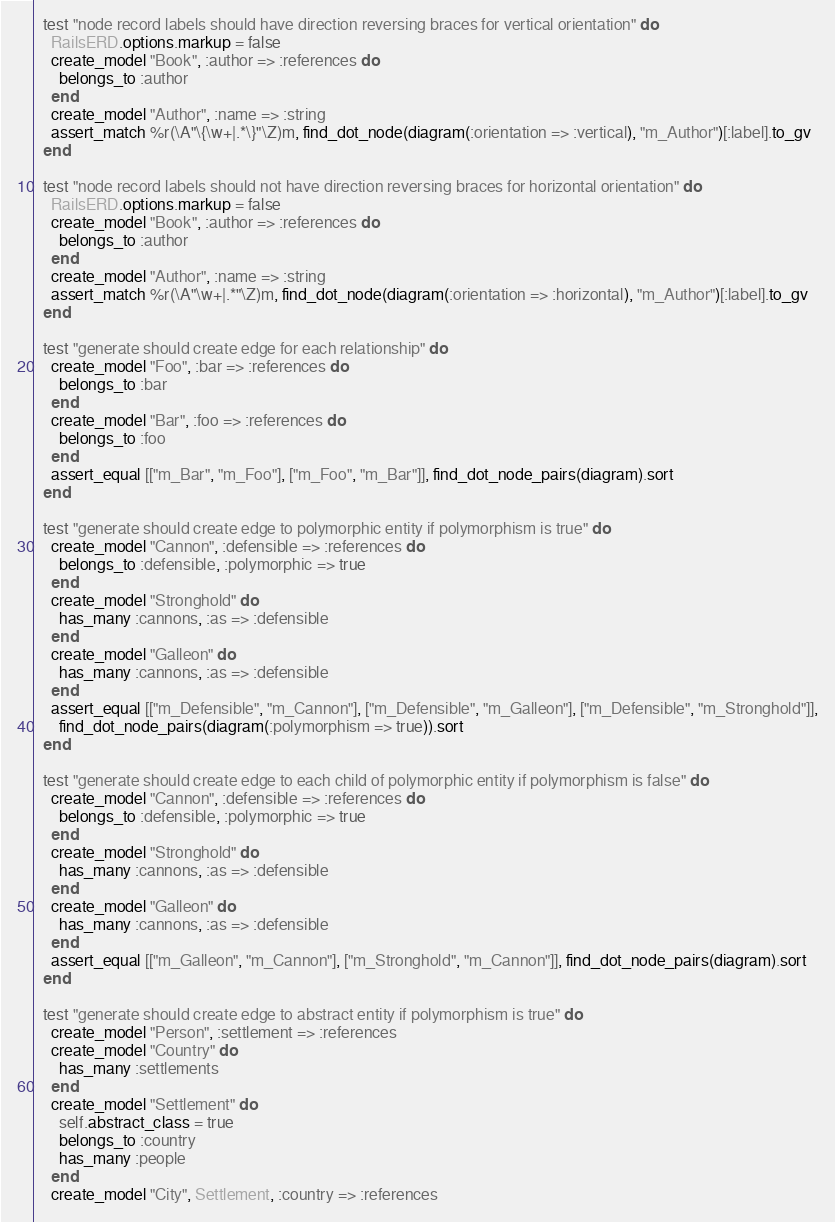<code> <loc_0><loc_0><loc_500><loc_500><_Ruby_>
  test "node record labels should have direction reversing braces for vertical orientation" do
    RailsERD.options.markup = false
    create_model "Book", :author => :references do
      belongs_to :author
    end
    create_model "Author", :name => :string
    assert_match %r(\A"\{\w+|.*\}"\Z)m, find_dot_node(diagram(:orientation => :vertical), "m_Author")[:label].to_gv
  end

  test "node record labels should not have direction reversing braces for horizontal orientation" do
    RailsERD.options.markup = false
    create_model "Book", :author => :references do
      belongs_to :author
    end
    create_model "Author", :name => :string
    assert_match %r(\A"\w+|.*"\Z)m, find_dot_node(diagram(:orientation => :horizontal), "m_Author")[:label].to_gv
  end

  test "generate should create edge for each relationship" do
    create_model "Foo", :bar => :references do
      belongs_to :bar
    end
    create_model "Bar", :foo => :references do
      belongs_to :foo
    end
    assert_equal [["m_Bar", "m_Foo"], ["m_Foo", "m_Bar"]], find_dot_node_pairs(diagram).sort
  end

  test "generate should create edge to polymorphic entity if polymorphism is true" do
    create_model "Cannon", :defensible => :references do
      belongs_to :defensible, :polymorphic => true
    end
    create_model "Stronghold" do
      has_many :cannons, :as => :defensible
    end
    create_model "Galleon" do
      has_many :cannons, :as => :defensible
    end
    assert_equal [["m_Defensible", "m_Cannon"], ["m_Defensible", "m_Galleon"], ["m_Defensible", "m_Stronghold"]],
      find_dot_node_pairs(diagram(:polymorphism => true)).sort
  end

  test "generate should create edge to each child of polymorphic entity if polymorphism is false" do
    create_model "Cannon", :defensible => :references do
      belongs_to :defensible, :polymorphic => true
    end
    create_model "Stronghold" do
      has_many :cannons, :as => :defensible
    end
    create_model "Galleon" do
      has_many :cannons, :as => :defensible
    end
    assert_equal [["m_Galleon", "m_Cannon"], ["m_Stronghold", "m_Cannon"]], find_dot_node_pairs(diagram).sort
  end

  test "generate should create edge to abstract entity if polymorphism is true" do
    create_model "Person", :settlement => :references
    create_model "Country" do
      has_many :settlements
    end
    create_model "Settlement" do
      self.abstract_class = true
      belongs_to :country
      has_many :people
    end
    create_model "City", Settlement, :country => :references</code> 